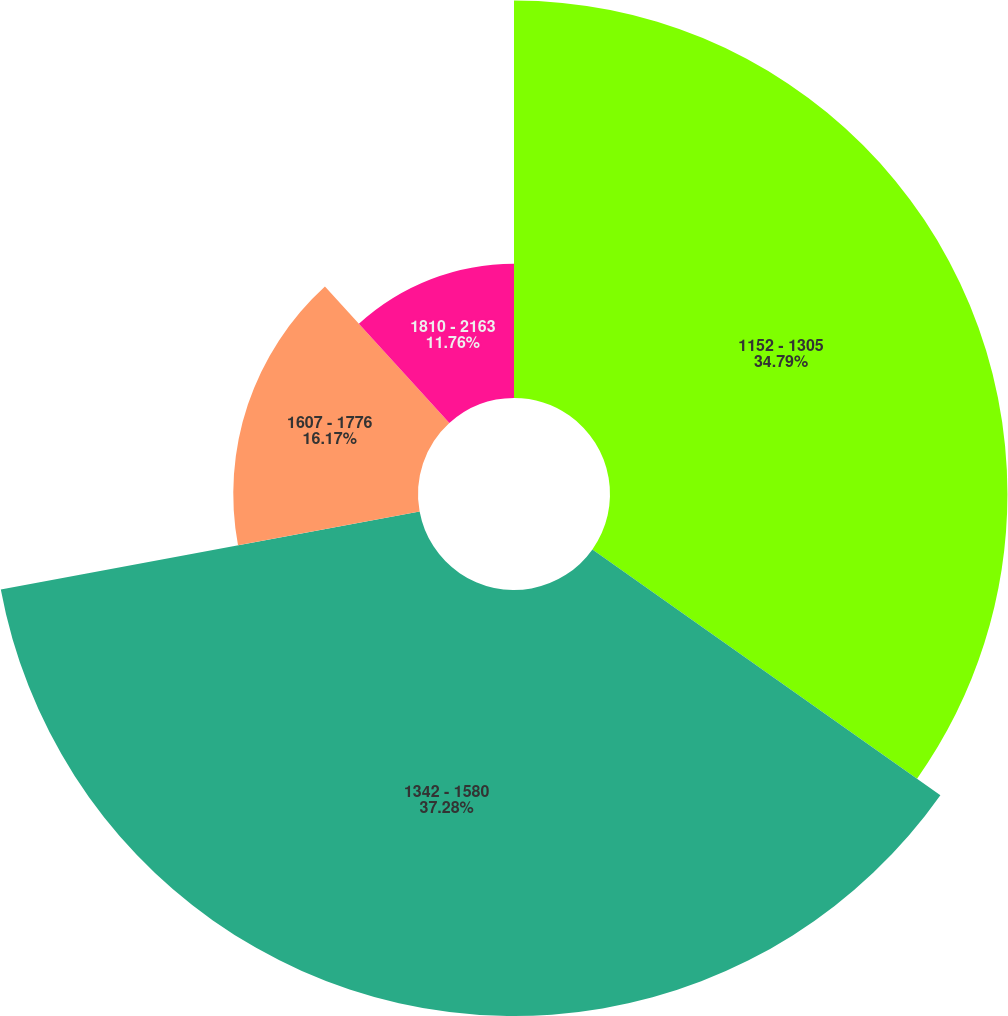Convert chart. <chart><loc_0><loc_0><loc_500><loc_500><pie_chart><fcel>1152 - 1305<fcel>1342 - 1580<fcel>1607 - 1776<fcel>1810 - 2163<nl><fcel>34.79%<fcel>37.29%<fcel>16.17%<fcel>11.76%<nl></chart> 